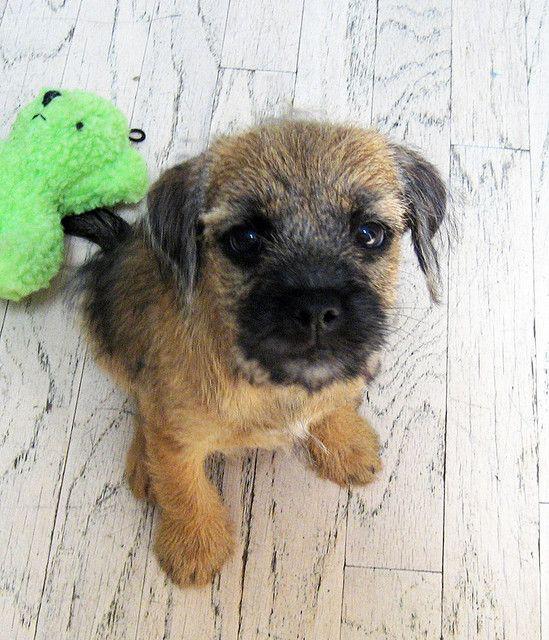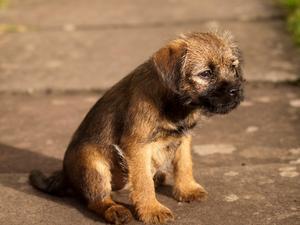The first image is the image on the left, the second image is the image on the right. Evaluate the accuracy of this statement regarding the images: "The left and right image contains the same number of dogs with at least one sitting.". Is it true? Answer yes or no. Yes. The first image is the image on the left, the second image is the image on the right. Analyze the images presented: Is the assertion "There are exactly two puppies, one in each image, and both of their faces are visible." valid? Answer yes or no. Yes. 